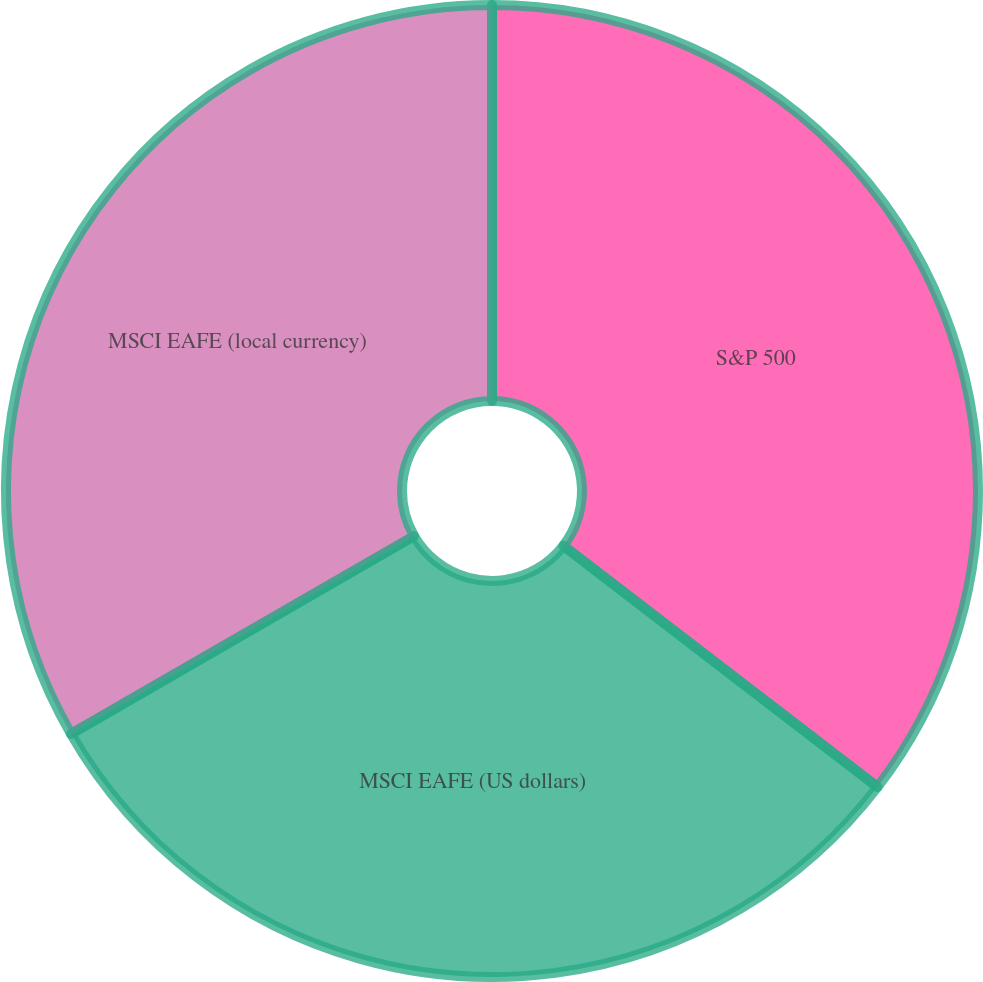Convert chart to OTSL. <chart><loc_0><loc_0><loc_500><loc_500><pie_chart><fcel>S&P 500<fcel>MSCI EAFE (US dollars)<fcel>MSCI EAFE (local currency)<nl><fcel>35.42%<fcel>31.25%<fcel>33.33%<nl></chart> 